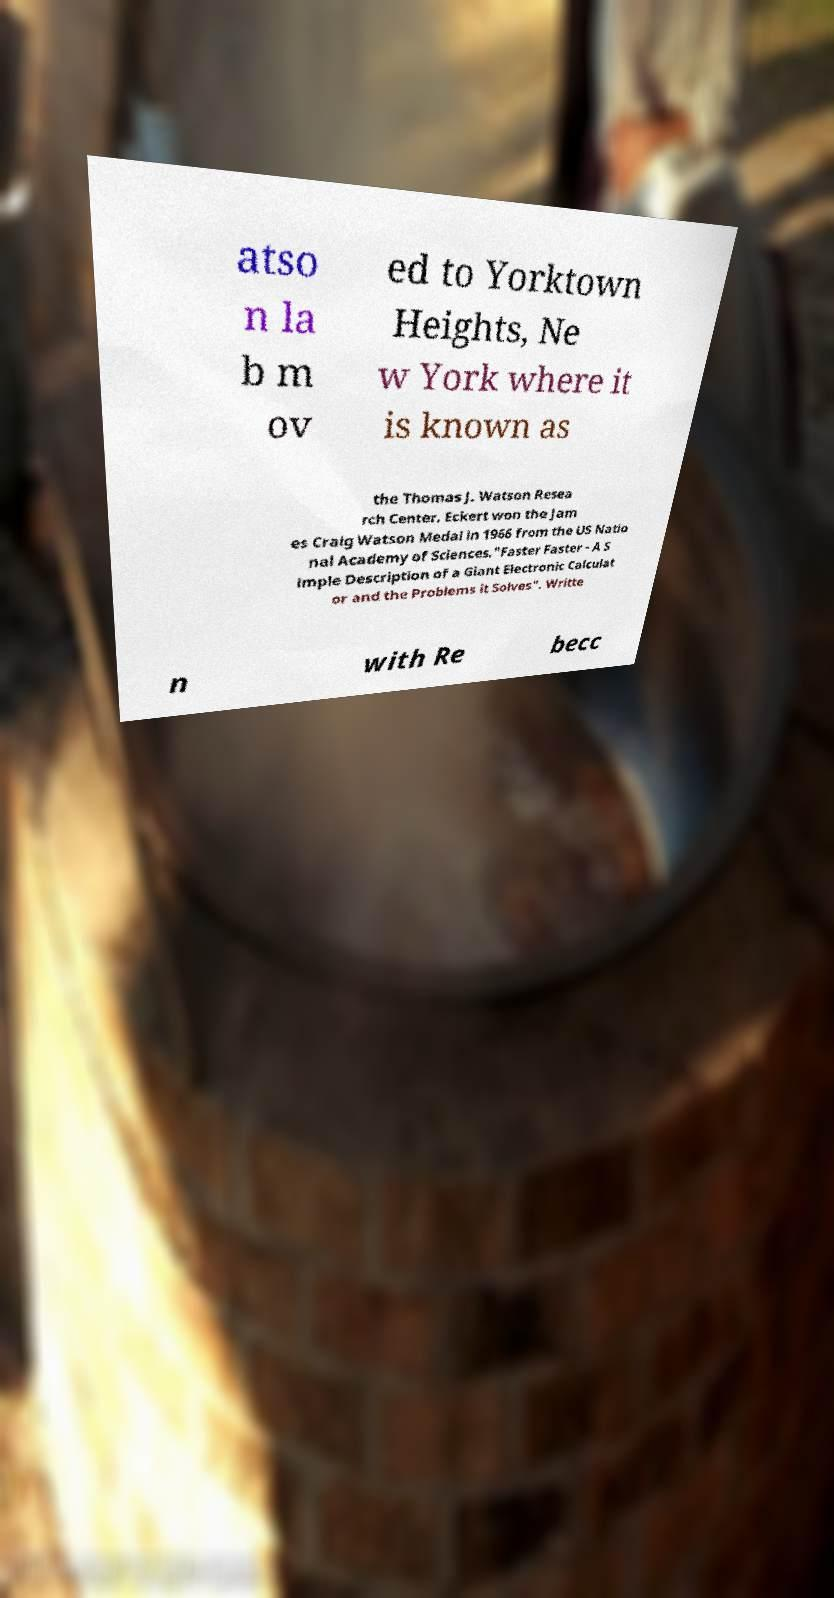I need the written content from this picture converted into text. Can you do that? atso n la b m ov ed to Yorktown Heights, Ne w York where it is known as the Thomas J. Watson Resea rch Center. Eckert won the Jam es Craig Watson Medal in 1966 from the US Natio nal Academy of Sciences."Faster Faster - A S imple Description of a Giant Electronic Calculat or and the Problems it Solves". Writte n with Re becc 